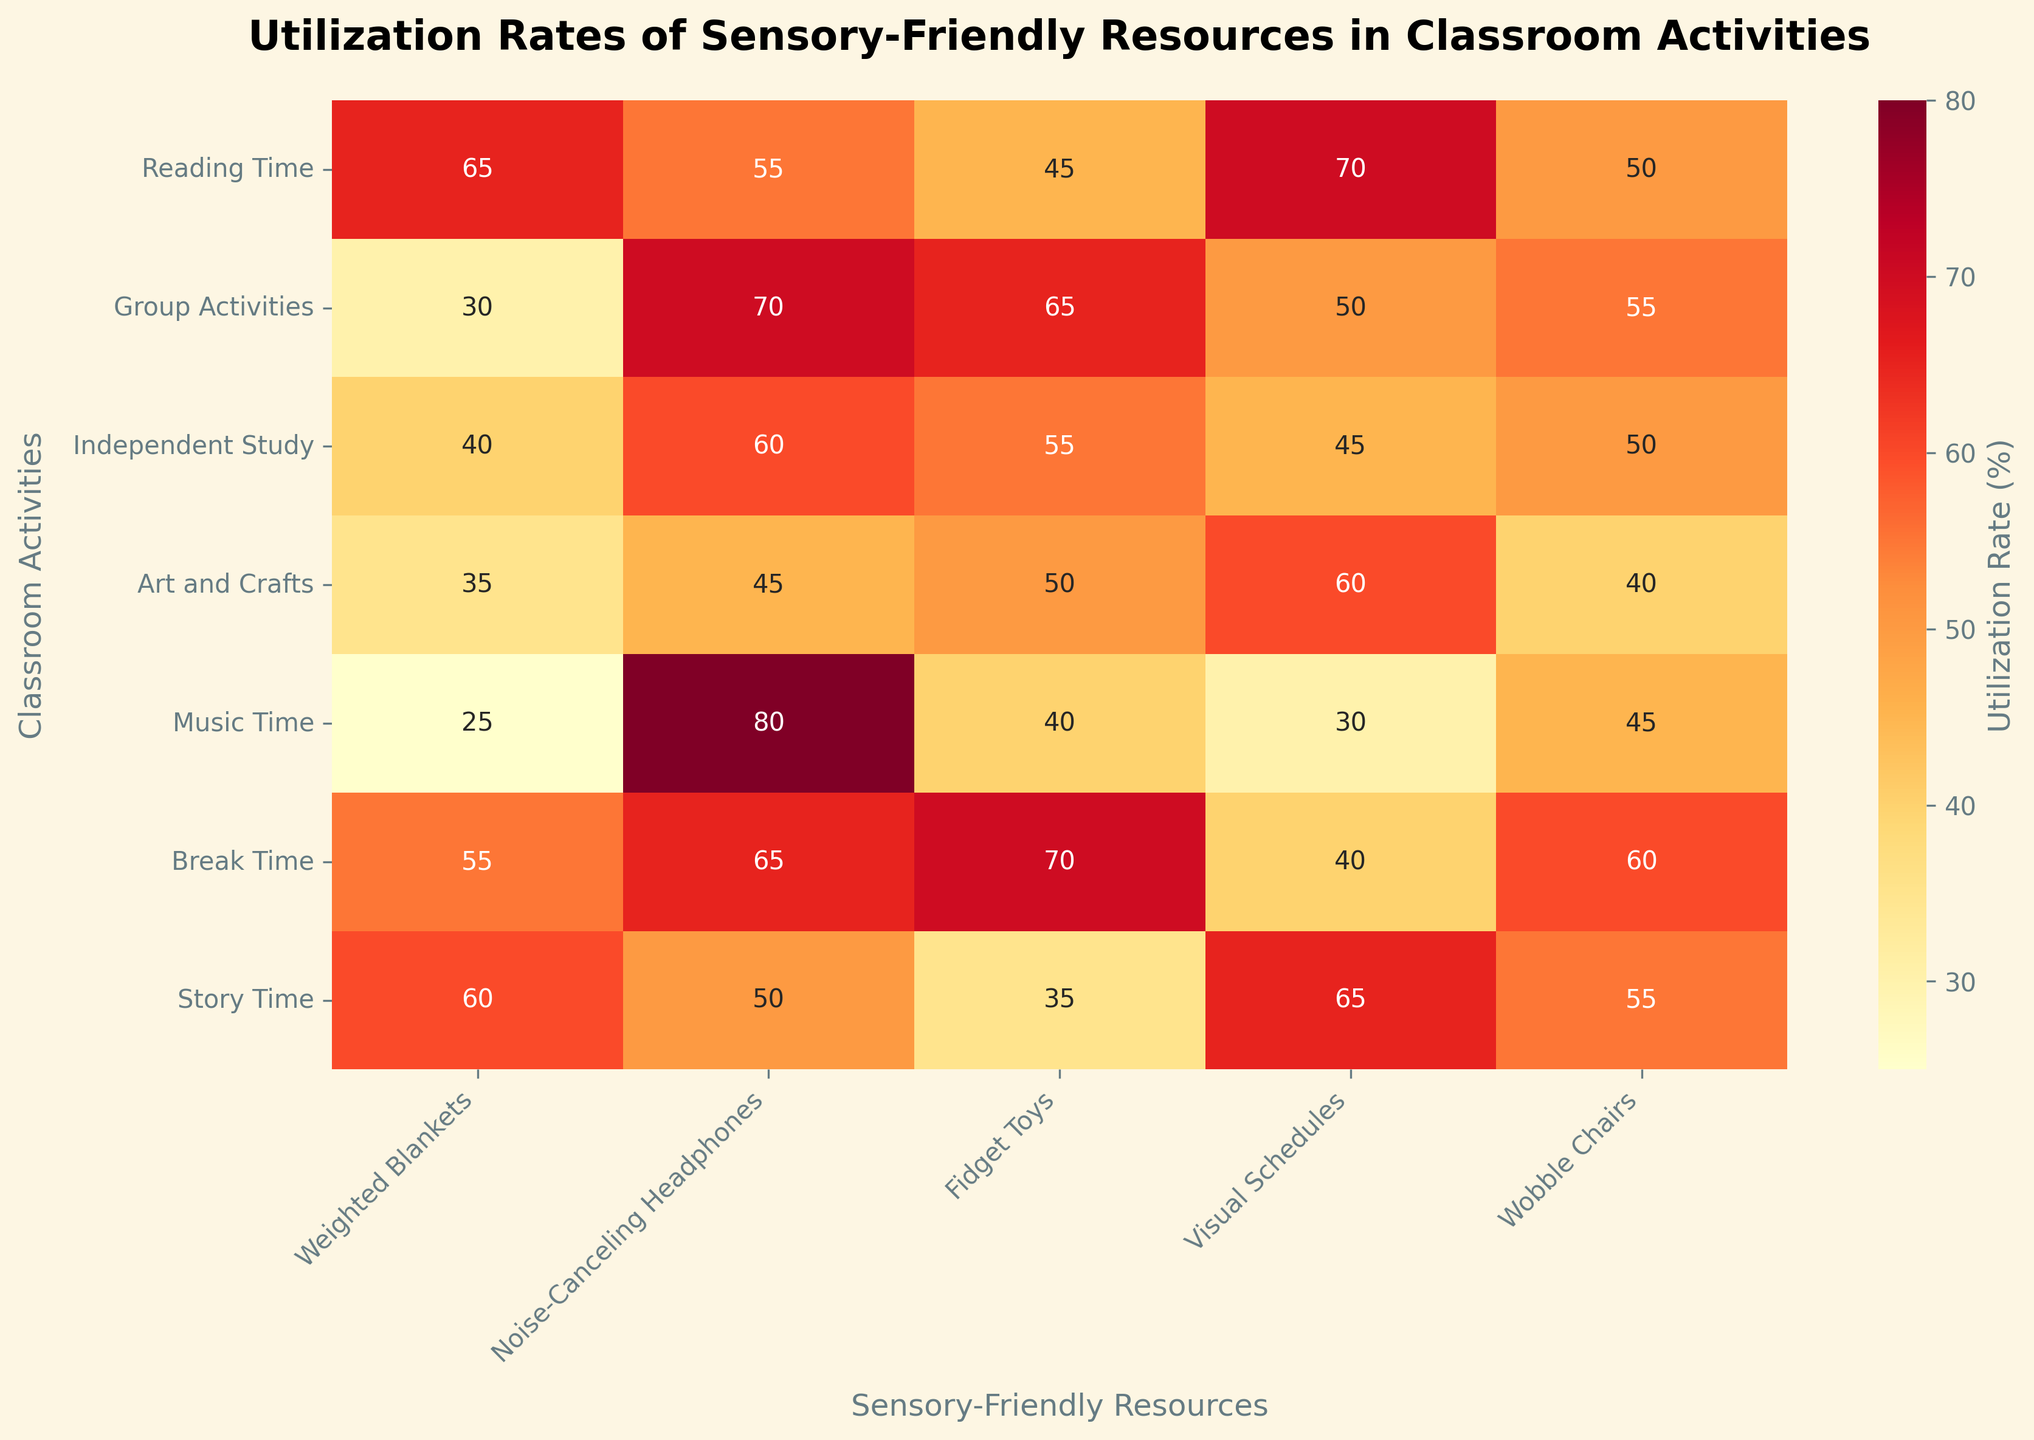What's the title of the heatmap? The title is usually located at the top of the figure. It provides an overview of what the chart is about. In this case, the title reads "Utilization Rates of Sensory-Friendly Resources in Classroom Activities".
Answer: Utilization Rates of Sensory-Friendly Resources in Classroom Activities What are the classroom activities represented on the y-axis? The y-axis lists the names of the classroom activities included in the study. Based on the data and figure, the activities are "Reading Time", "Group Activities", "Independent Study", "Art and Crafts", "Music Time", "Break Time", and "Story Time".
Answer: Reading Time, Group Activities, Independent Study, Art and Crafts, Music Time, Break Time, Story Time Which sensory-friendly resource has the highest utilization rate during "Music Time"? Locate the row for "Music Time" and identify the highest value in that row. The values for "Music Time" are 25, 80, 40, 30, and 45. The highest value is 80, which corresponds to "Noise-Canceling Headphones".
Answer: Noise-Canceling Headphones What are the utilization rates of Weighted Blankets during "Reading Time" and "Music Time", and what is their difference? First, find the utilization rate of Weighted Blankets during "Reading Time" and "Music Time". These values are 65 and 25, respectively. The difference is calculated by subtracting 25 from 65.
Answer: 40 Which classroom activity has the highest utilization rate for Fidget Toys? Look at the column for Fidget Toys and identify the highest value. The values are 45, 65, 55, 50, 40, 70, and 35. The highest value is 70, which corresponds to "Break Time".
Answer: Break Time Which sensory-friendly resource is least utilized during "Story Time"? Focus on the "Story Time" row and find the smallest value. The values are 60, 50, 35, 65, and 55. The smallest value is 35, which corresponds to "Fidget Toys".
Answer: Fidget Toys What is the average utilization rate of Visual Schedules across all activities? To find the average, sum all the values for Visual Schedules and divide by the number of activities. The values are 70, 50, 45, 60, 30, 40, and 65. The sum is (70 + 50 + 45 + 60 + 30 + 40 + 65) = 360. The average is 360 divided by 7.
Answer: 51.4 In which two classroom activities are Noise-Canceling Headphones most utilized, and what are their rates? Locate the column for Noise-Canceling Headphones and identify the two highest values. The values are 55, 70, 60, 45, 80, 65, and 50. The highest values are 80 and 70, which correspond to "Music Time" and "Group Activities".
Answer: Music Time (80), Group Activities (70) How many activities have a utilization rate of 50% or higher for Wobble Chairs? Look at the column for Wobble Chairs and count the activities with values of 50 or more. The values are 50, 55, 50, 40, 45, 60, and 55. The activities with values of 50 or higher are "Reading Time", "Group Activities", "Independent Study", "Break Time", and "Story Time".
Answer: 5 What's the total utilization rate of all resources during "Break Time"? Add the values of all resources during "Break Time". The values are 55, 65, 70, 40, and 60. The sum is 55 + 65 + 70 + 40 + 60.
Answer: 290 